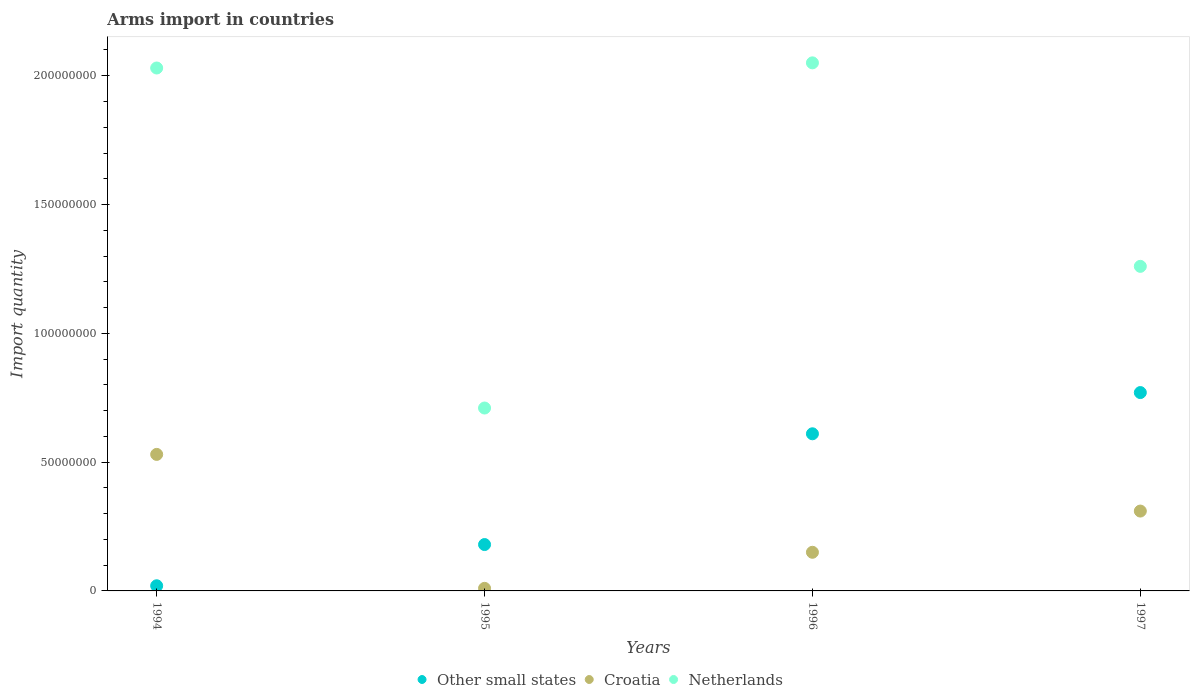What is the total arms import in Croatia in 1996?
Keep it short and to the point. 1.50e+07. Across all years, what is the maximum total arms import in Croatia?
Your answer should be very brief. 5.30e+07. Across all years, what is the minimum total arms import in Other small states?
Offer a terse response. 2.00e+06. In which year was the total arms import in Netherlands maximum?
Offer a terse response. 1996. What is the difference between the total arms import in Other small states in 1995 and that in 1996?
Your response must be concise. -4.30e+07. What is the difference between the total arms import in Croatia in 1997 and the total arms import in Other small states in 1996?
Ensure brevity in your answer.  -3.00e+07. What is the average total arms import in Croatia per year?
Offer a very short reply. 2.50e+07. In the year 1994, what is the difference between the total arms import in Other small states and total arms import in Netherlands?
Give a very brief answer. -2.01e+08. In how many years, is the total arms import in Netherlands greater than 180000000?
Your answer should be very brief. 2. What is the ratio of the total arms import in Croatia in 1994 to that in 1996?
Offer a very short reply. 3.53. Is the total arms import in Croatia in 1996 less than that in 1997?
Give a very brief answer. Yes. Is the difference between the total arms import in Other small states in 1994 and 1995 greater than the difference between the total arms import in Netherlands in 1994 and 1995?
Give a very brief answer. No. What is the difference between the highest and the second highest total arms import in Netherlands?
Your response must be concise. 2.00e+06. What is the difference between the highest and the lowest total arms import in Croatia?
Ensure brevity in your answer.  5.20e+07. Is the sum of the total arms import in Netherlands in 1995 and 1996 greater than the maximum total arms import in Other small states across all years?
Ensure brevity in your answer.  Yes. Does the total arms import in Netherlands monotonically increase over the years?
Provide a short and direct response. No. Is the total arms import in Netherlands strictly greater than the total arms import in Croatia over the years?
Give a very brief answer. Yes. Is the total arms import in Other small states strictly less than the total arms import in Netherlands over the years?
Ensure brevity in your answer.  Yes. Does the graph contain grids?
Your response must be concise. No. Where does the legend appear in the graph?
Your response must be concise. Bottom center. How are the legend labels stacked?
Give a very brief answer. Horizontal. What is the title of the graph?
Ensure brevity in your answer.  Arms import in countries. Does "Heavily indebted poor countries" appear as one of the legend labels in the graph?
Keep it short and to the point. No. What is the label or title of the Y-axis?
Ensure brevity in your answer.  Import quantity. What is the Import quantity of Other small states in 1994?
Keep it short and to the point. 2.00e+06. What is the Import quantity in Croatia in 1994?
Ensure brevity in your answer.  5.30e+07. What is the Import quantity of Netherlands in 1994?
Ensure brevity in your answer.  2.03e+08. What is the Import quantity of Other small states in 1995?
Keep it short and to the point. 1.80e+07. What is the Import quantity of Netherlands in 1995?
Make the answer very short. 7.10e+07. What is the Import quantity of Other small states in 1996?
Offer a very short reply. 6.10e+07. What is the Import quantity in Croatia in 1996?
Offer a terse response. 1.50e+07. What is the Import quantity in Netherlands in 1996?
Give a very brief answer. 2.05e+08. What is the Import quantity in Other small states in 1997?
Give a very brief answer. 7.70e+07. What is the Import quantity of Croatia in 1997?
Make the answer very short. 3.10e+07. What is the Import quantity of Netherlands in 1997?
Give a very brief answer. 1.26e+08. Across all years, what is the maximum Import quantity of Other small states?
Ensure brevity in your answer.  7.70e+07. Across all years, what is the maximum Import quantity in Croatia?
Offer a terse response. 5.30e+07. Across all years, what is the maximum Import quantity of Netherlands?
Keep it short and to the point. 2.05e+08. Across all years, what is the minimum Import quantity in Other small states?
Offer a very short reply. 2.00e+06. Across all years, what is the minimum Import quantity in Croatia?
Ensure brevity in your answer.  1.00e+06. Across all years, what is the minimum Import quantity of Netherlands?
Make the answer very short. 7.10e+07. What is the total Import quantity of Other small states in the graph?
Offer a very short reply. 1.58e+08. What is the total Import quantity in Croatia in the graph?
Your answer should be compact. 1.00e+08. What is the total Import quantity of Netherlands in the graph?
Offer a very short reply. 6.05e+08. What is the difference between the Import quantity in Other small states in 1994 and that in 1995?
Provide a short and direct response. -1.60e+07. What is the difference between the Import quantity in Croatia in 1994 and that in 1995?
Keep it short and to the point. 5.20e+07. What is the difference between the Import quantity in Netherlands in 1994 and that in 1995?
Your answer should be compact. 1.32e+08. What is the difference between the Import quantity of Other small states in 1994 and that in 1996?
Provide a succinct answer. -5.90e+07. What is the difference between the Import quantity of Croatia in 1994 and that in 1996?
Your answer should be compact. 3.80e+07. What is the difference between the Import quantity of Other small states in 1994 and that in 1997?
Offer a terse response. -7.50e+07. What is the difference between the Import quantity in Croatia in 1994 and that in 1997?
Ensure brevity in your answer.  2.20e+07. What is the difference between the Import quantity of Netherlands in 1994 and that in 1997?
Offer a terse response. 7.70e+07. What is the difference between the Import quantity of Other small states in 1995 and that in 1996?
Provide a succinct answer. -4.30e+07. What is the difference between the Import quantity of Croatia in 1995 and that in 1996?
Offer a very short reply. -1.40e+07. What is the difference between the Import quantity in Netherlands in 1995 and that in 1996?
Give a very brief answer. -1.34e+08. What is the difference between the Import quantity of Other small states in 1995 and that in 1997?
Provide a short and direct response. -5.90e+07. What is the difference between the Import quantity of Croatia in 1995 and that in 1997?
Your answer should be very brief. -3.00e+07. What is the difference between the Import quantity in Netherlands in 1995 and that in 1997?
Provide a short and direct response. -5.50e+07. What is the difference between the Import quantity in Other small states in 1996 and that in 1997?
Your answer should be very brief. -1.60e+07. What is the difference between the Import quantity of Croatia in 1996 and that in 1997?
Give a very brief answer. -1.60e+07. What is the difference between the Import quantity of Netherlands in 1996 and that in 1997?
Ensure brevity in your answer.  7.90e+07. What is the difference between the Import quantity of Other small states in 1994 and the Import quantity of Croatia in 1995?
Ensure brevity in your answer.  1.00e+06. What is the difference between the Import quantity in Other small states in 1994 and the Import quantity in Netherlands in 1995?
Your response must be concise. -6.90e+07. What is the difference between the Import quantity in Croatia in 1994 and the Import quantity in Netherlands in 1995?
Offer a terse response. -1.80e+07. What is the difference between the Import quantity of Other small states in 1994 and the Import quantity of Croatia in 1996?
Give a very brief answer. -1.30e+07. What is the difference between the Import quantity in Other small states in 1994 and the Import quantity in Netherlands in 1996?
Your answer should be compact. -2.03e+08. What is the difference between the Import quantity of Croatia in 1994 and the Import quantity of Netherlands in 1996?
Keep it short and to the point. -1.52e+08. What is the difference between the Import quantity of Other small states in 1994 and the Import quantity of Croatia in 1997?
Provide a succinct answer. -2.90e+07. What is the difference between the Import quantity in Other small states in 1994 and the Import quantity in Netherlands in 1997?
Give a very brief answer. -1.24e+08. What is the difference between the Import quantity in Croatia in 1994 and the Import quantity in Netherlands in 1997?
Your answer should be very brief. -7.30e+07. What is the difference between the Import quantity in Other small states in 1995 and the Import quantity in Netherlands in 1996?
Provide a succinct answer. -1.87e+08. What is the difference between the Import quantity in Croatia in 1995 and the Import quantity in Netherlands in 1996?
Provide a succinct answer. -2.04e+08. What is the difference between the Import quantity of Other small states in 1995 and the Import quantity of Croatia in 1997?
Your answer should be very brief. -1.30e+07. What is the difference between the Import quantity in Other small states in 1995 and the Import quantity in Netherlands in 1997?
Make the answer very short. -1.08e+08. What is the difference between the Import quantity of Croatia in 1995 and the Import quantity of Netherlands in 1997?
Provide a succinct answer. -1.25e+08. What is the difference between the Import quantity of Other small states in 1996 and the Import quantity of Croatia in 1997?
Make the answer very short. 3.00e+07. What is the difference between the Import quantity of Other small states in 1996 and the Import quantity of Netherlands in 1997?
Keep it short and to the point. -6.50e+07. What is the difference between the Import quantity of Croatia in 1996 and the Import quantity of Netherlands in 1997?
Give a very brief answer. -1.11e+08. What is the average Import quantity in Other small states per year?
Keep it short and to the point. 3.95e+07. What is the average Import quantity in Croatia per year?
Keep it short and to the point. 2.50e+07. What is the average Import quantity in Netherlands per year?
Your answer should be very brief. 1.51e+08. In the year 1994, what is the difference between the Import quantity in Other small states and Import quantity in Croatia?
Make the answer very short. -5.10e+07. In the year 1994, what is the difference between the Import quantity in Other small states and Import quantity in Netherlands?
Provide a short and direct response. -2.01e+08. In the year 1994, what is the difference between the Import quantity in Croatia and Import quantity in Netherlands?
Give a very brief answer. -1.50e+08. In the year 1995, what is the difference between the Import quantity of Other small states and Import quantity of Croatia?
Offer a very short reply. 1.70e+07. In the year 1995, what is the difference between the Import quantity in Other small states and Import quantity in Netherlands?
Make the answer very short. -5.30e+07. In the year 1995, what is the difference between the Import quantity of Croatia and Import quantity of Netherlands?
Offer a terse response. -7.00e+07. In the year 1996, what is the difference between the Import quantity of Other small states and Import quantity of Croatia?
Offer a very short reply. 4.60e+07. In the year 1996, what is the difference between the Import quantity in Other small states and Import quantity in Netherlands?
Offer a very short reply. -1.44e+08. In the year 1996, what is the difference between the Import quantity of Croatia and Import quantity of Netherlands?
Your answer should be compact. -1.90e+08. In the year 1997, what is the difference between the Import quantity of Other small states and Import quantity of Croatia?
Give a very brief answer. 4.60e+07. In the year 1997, what is the difference between the Import quantity of Other small states and Import quantity of Netherlands?
Your response must be concise. -4.90e+07. In the year 1997, what is the difference between the Import quantity in Croatia and Import quantity in Netherlands?
Ensure brevity in your answer.  -9.50e+07. What is the ratio of the Import quantity of Croatia in 1994 to that in 1995?
Keep it short and to the point. 53. What is the ratio of the Import quantity in Netherlands in 1994 to that in 1995?
Offer a very short reply. 2.86. What is the ratio of the Import quantity of Other small states in 1994 to that in 1996?
Keep it short and to the point. 0.03. What is the ratio of the Import quantity in Croatia in 1994 to that in 1996?
Offer a terse response. 3.53. What is the ratio of the Import quantity in Netherlands in 1994 to that in 1996?
Offer a very short reply. 0.99. What is the ratio of the Import quantity of Other small states in 1994 to that in 1997?
Your answer should be very brief. 0.03. What is the ratio of the Import quantity of Croatia in 1994 to that in 1997?
Provide a succinct answer. 1.71. What is the ratio of the Import quantity in Netherlands in 1994 to that in 1997?
Keep it short and to the point. 1.61. What is the ratio of the Import quantity in Other small states in 1995 to that in 1996?
Provide a short and direct response. 0.3. What is the ratio of the Import quantity of Croatia in 1995 to that in 1996?
Make the answer very short. 0.07. What is the ratio of the Import quantity of Netherlands in 1995 to that in 1996?
Ensure brevity in your answer.  0.35. What is the ratio of the Import quantity in Other small states in 1995 to that in 1997?
Provide a short and direct response. 0.23. What is the ratio of the Import quantity in Croatia in 1995 to that in 1997?
Your response must be concise. 0.03. What is the ratio of the Import quantity of Netherlands in 1995 to that in 1997?
Provide a short and direct response. 0.56. What is the ratio of the Import quantity in Other small states in 1996 to that in 1997?
Make the answer very short. 0.79. What is the ratio of the Import quantity of Croatia in 1996 to that in 1997?
Ensure brevity in your answer.  0.48. What is the ratio of the Import quantity in Netherlands in 1996 to that in 1997?
Ensure brevity in your answer.  1.63. What is the difference between the highest and the second highest Import quantity of Other small states?
Offer a terse response. 1.60e+07. What is the difference between the highest and the second highest Import quantity of Croatia?
Your answer should be very brief. 2.20e+07. What is the difference between the highest and the second highest Import quantity of Netherlands?
Your answer should be compact. 2.00e+06. What is the difference between the highest and the lowest Import quantity of Other small states?
Ensure brevity in your answer.  7.50e+07. What is the difference between the highest and the lowest Import quantity in Croatia?
Give a very brief answer. 5.20e+07. What is the difference between the highest and the lowest Import quantity of Netherlands?
Keep it short and to the point. 1.34e+08. 